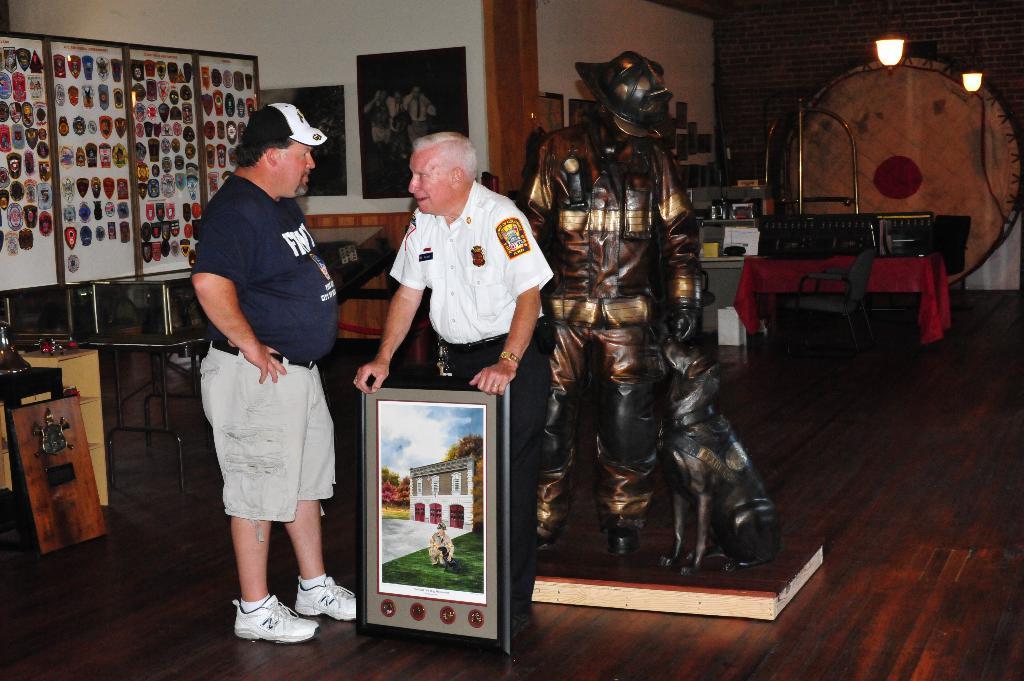Describe this image in one or two sentences. There are two men and a statue present at the bottom of this image. The person standing in the middle is holding a photo frame. We can see tables, photo frames and some other objects are present in the background. 